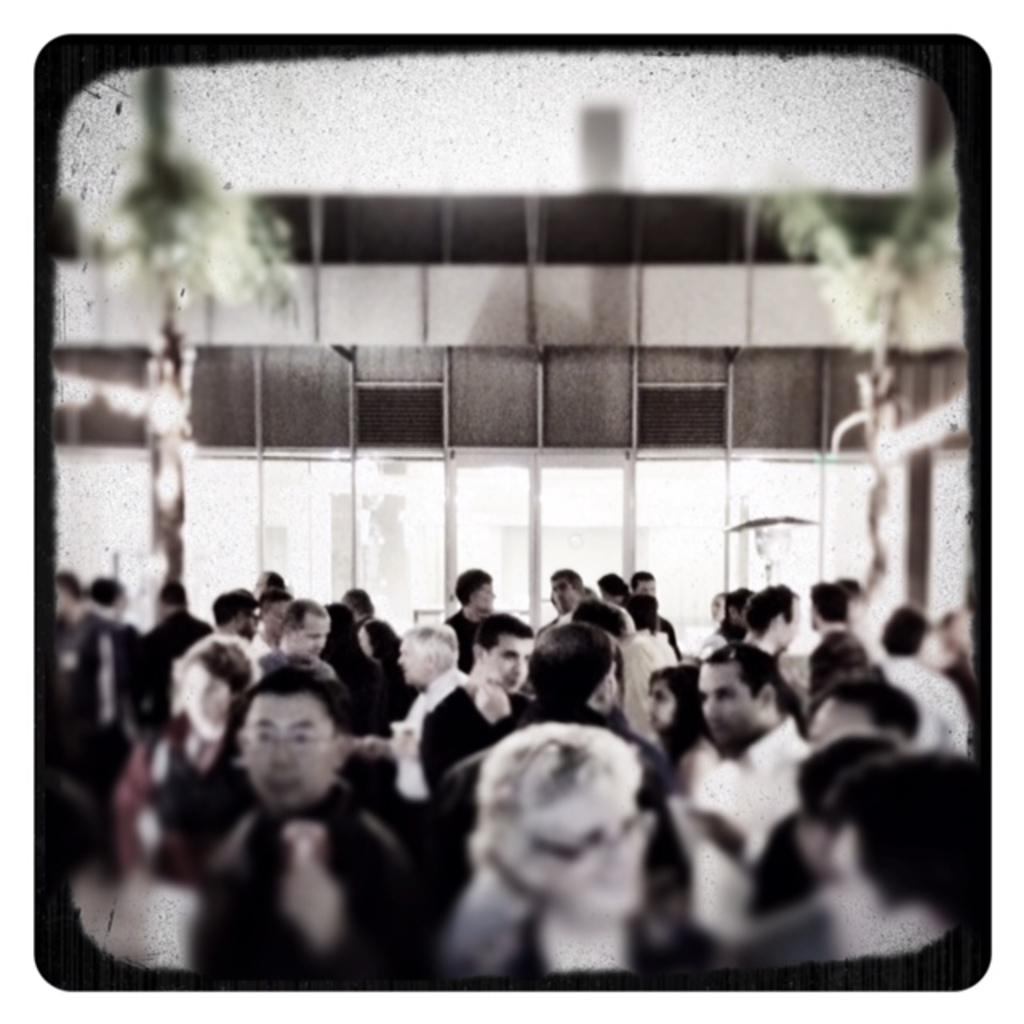How many people are visible in the foreground of the image? There are many people in the foreground of the image. What can be seen in the background of the image? There is a building in the background of the image. What type of vegetation is present at the top of the image? There are trees at the top of the image on either side. What type of gold can be seen in the image? There is no gold present in the image. How many times do the people in the image cough? The image does not show or indicate any coughing, so it cannot be determined. 